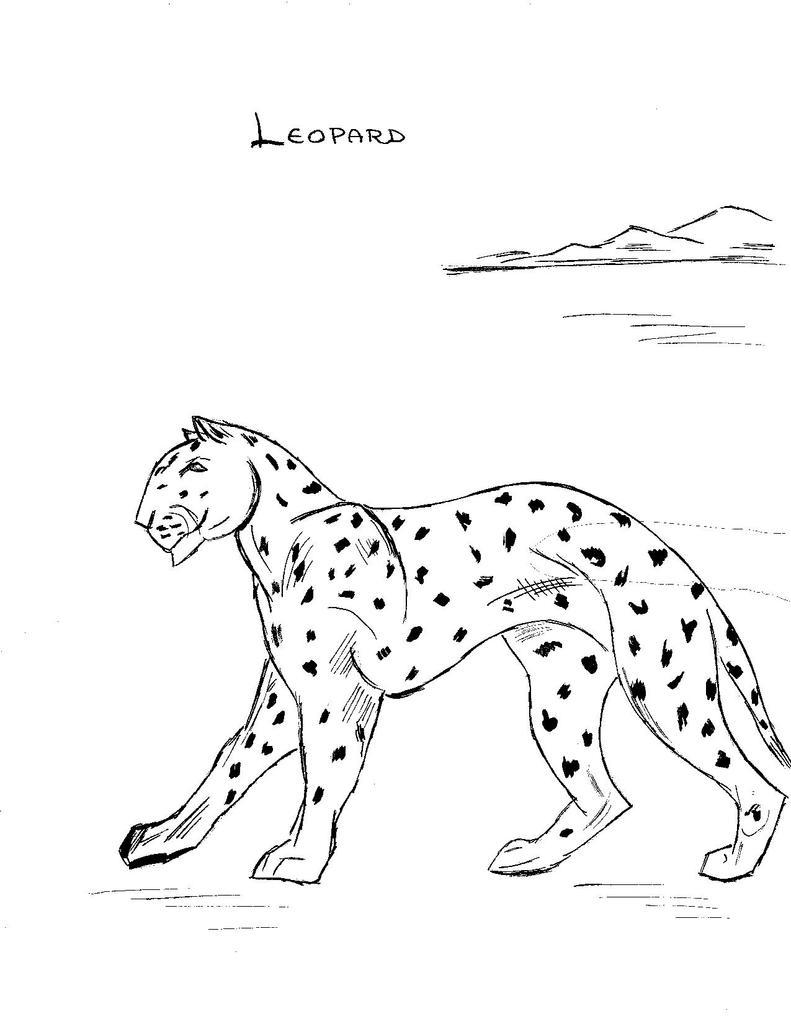What animal is depicted in the drawing in the image? There is a drawing of a leopard in the image. What type of landscape is shown in the image? There are hills depicted in the image. What is written at the top of the image? There is text visible at the top of the image. What color is the background of the image? The background of the image is white. Can you tell me how many passengers are being transported in the image? There is no reference to passengers or transportation in the image; it features a drawing of a leopard, hills, text, and a white background. What type of drink is being served in the image? There is no drink present in the image. 